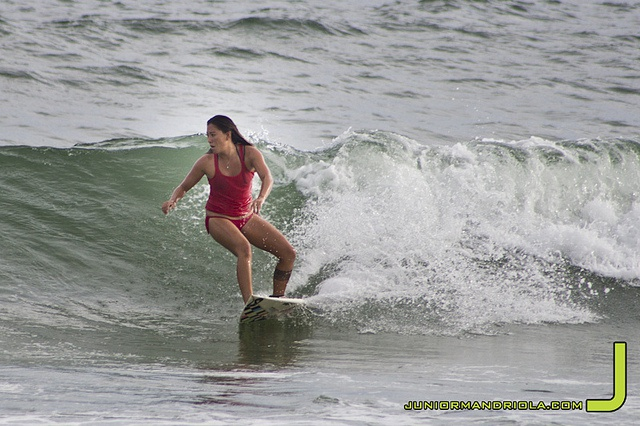Describe the objects in this image and their specific colors. I can see people in darkgray, maroon, and brown tones and surfboard in darkgray, gray, black, darkgreen, and beige tones in this image. 